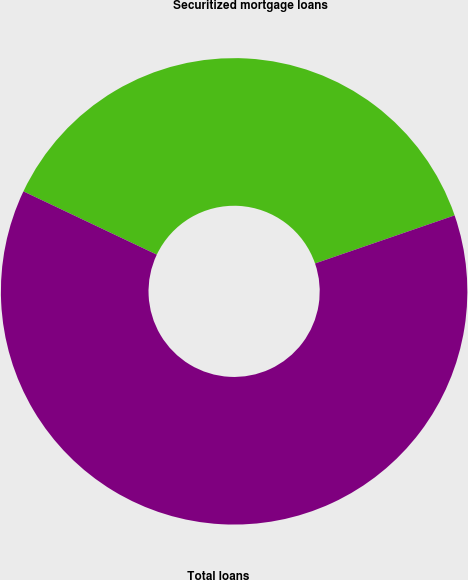Convert chart to OTSL. <chart><loc_0><loc_0><loc_500><loc_500><pie_chart><fcel>Securitized mortgage loans<fcel>Total loans<nl><fcel>37.67%<fcel>62.33%<nl></chart> 